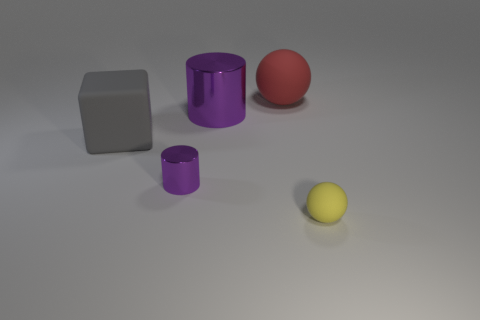Is there any other thing that has the same color as the block?
Your answer should be very brief. No. There is a large matte object that is in front of the ball to the left of the small yellow object; are there any small purple shiny objects in front of it?
Your response must be concise. Yes. What is the color of the tiny sphere?
Your answer should be compact. Yellow. There is a red object; are there any balls left of it?
Offer a very short reply. No. Does the big gray matte object have the same shape as the small thing behind the small ball?
Your response must be concise. No. How many other things are there of the same material as the yellow object?
Give a very brief answer. 2. What is the color of the small object that is right of the ball that is behind the tiny yellow matte object right of the large red object?
Your answer should be very brief. Yellow. What is the shape of the purple thing that is to the left of the purple cylinder on the right side of the tiny cylinder?
Your response must be concise. Cylinder. Are there more yellow matte spheres behind the small cylinder than large gray rubber cubes?
Provide a short and direct response. No. Do the small object on the left side of the small yellow ball and the large gray matte thing have the same shape?
Your answer should be compact. No. 